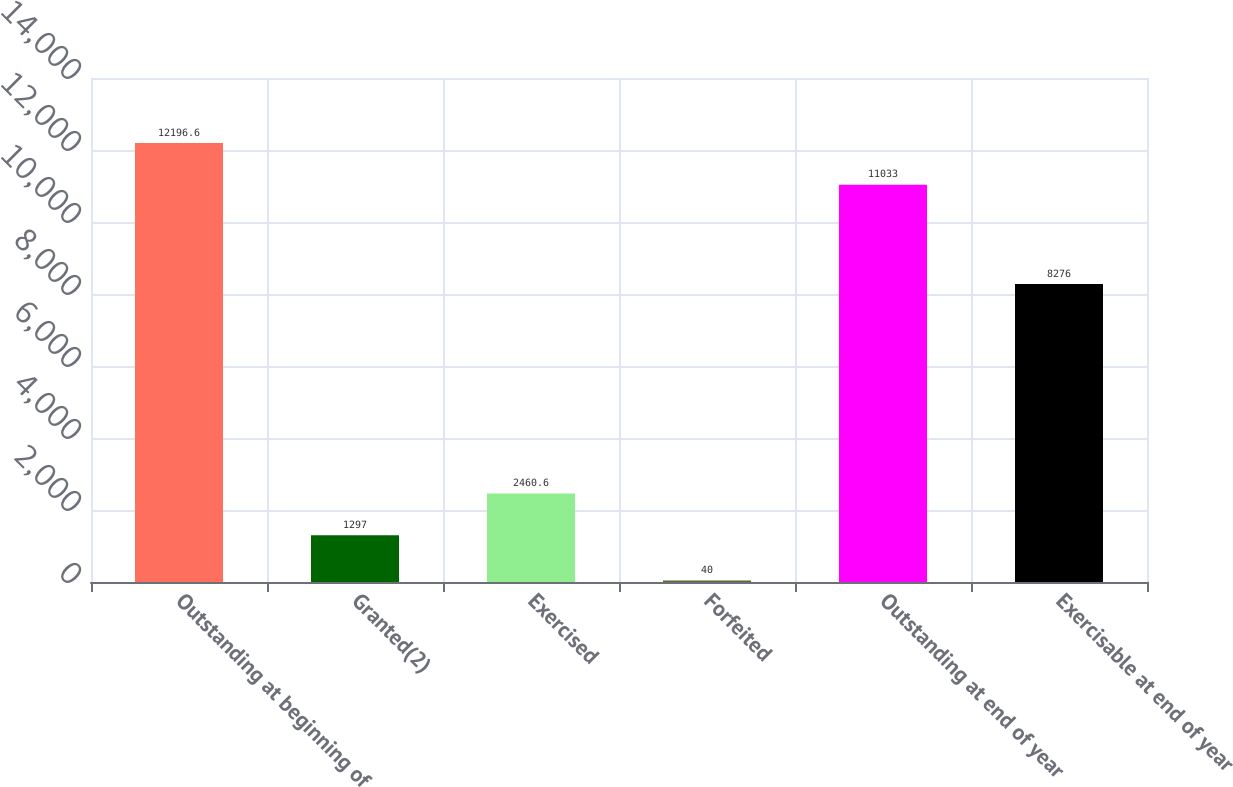Convert chart. <chart><loc_0><loc_0><loc_500><loc_500><bar_chart><fcel>Outstanding at beginning of<fcel>Granted(2)<fcel>Exercised<fcel>Forfeited<fcel>Outstanding at end of year<fcel>Exercisable at end of year<nl><fcel>12196.6<fcel>1297<fcel>2460.6<fcel>40<fcel>11033<fcel>8276<nl></chart> 